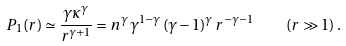<formula> <loc_0><loc_0><loc_500><loc_500>P _ { 1 } ( r ) \simeq \frac { \gamma \kappa ^ { \gamma } } { r ^ { \gamma + 1 } } = n ^ { \gamma } \, \gamma ^ { 1 - \gamma } \, ( \gamma - 1 ) ^ { \gamma } \, r ^ { - \gamma - 1 } \quad ( r \gg 1 ) \, .</formula> 